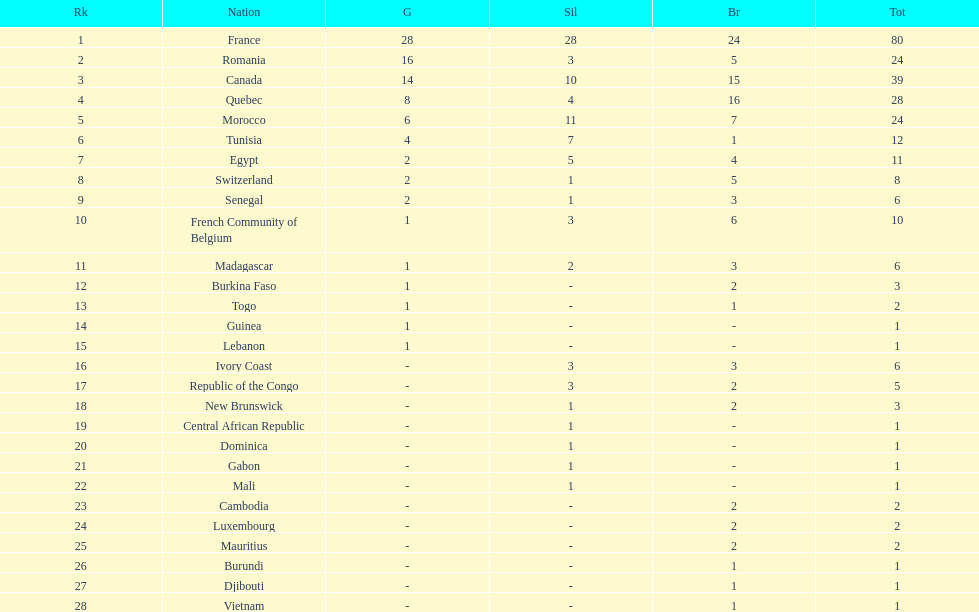How many nations won at least 10 medals? 8. 